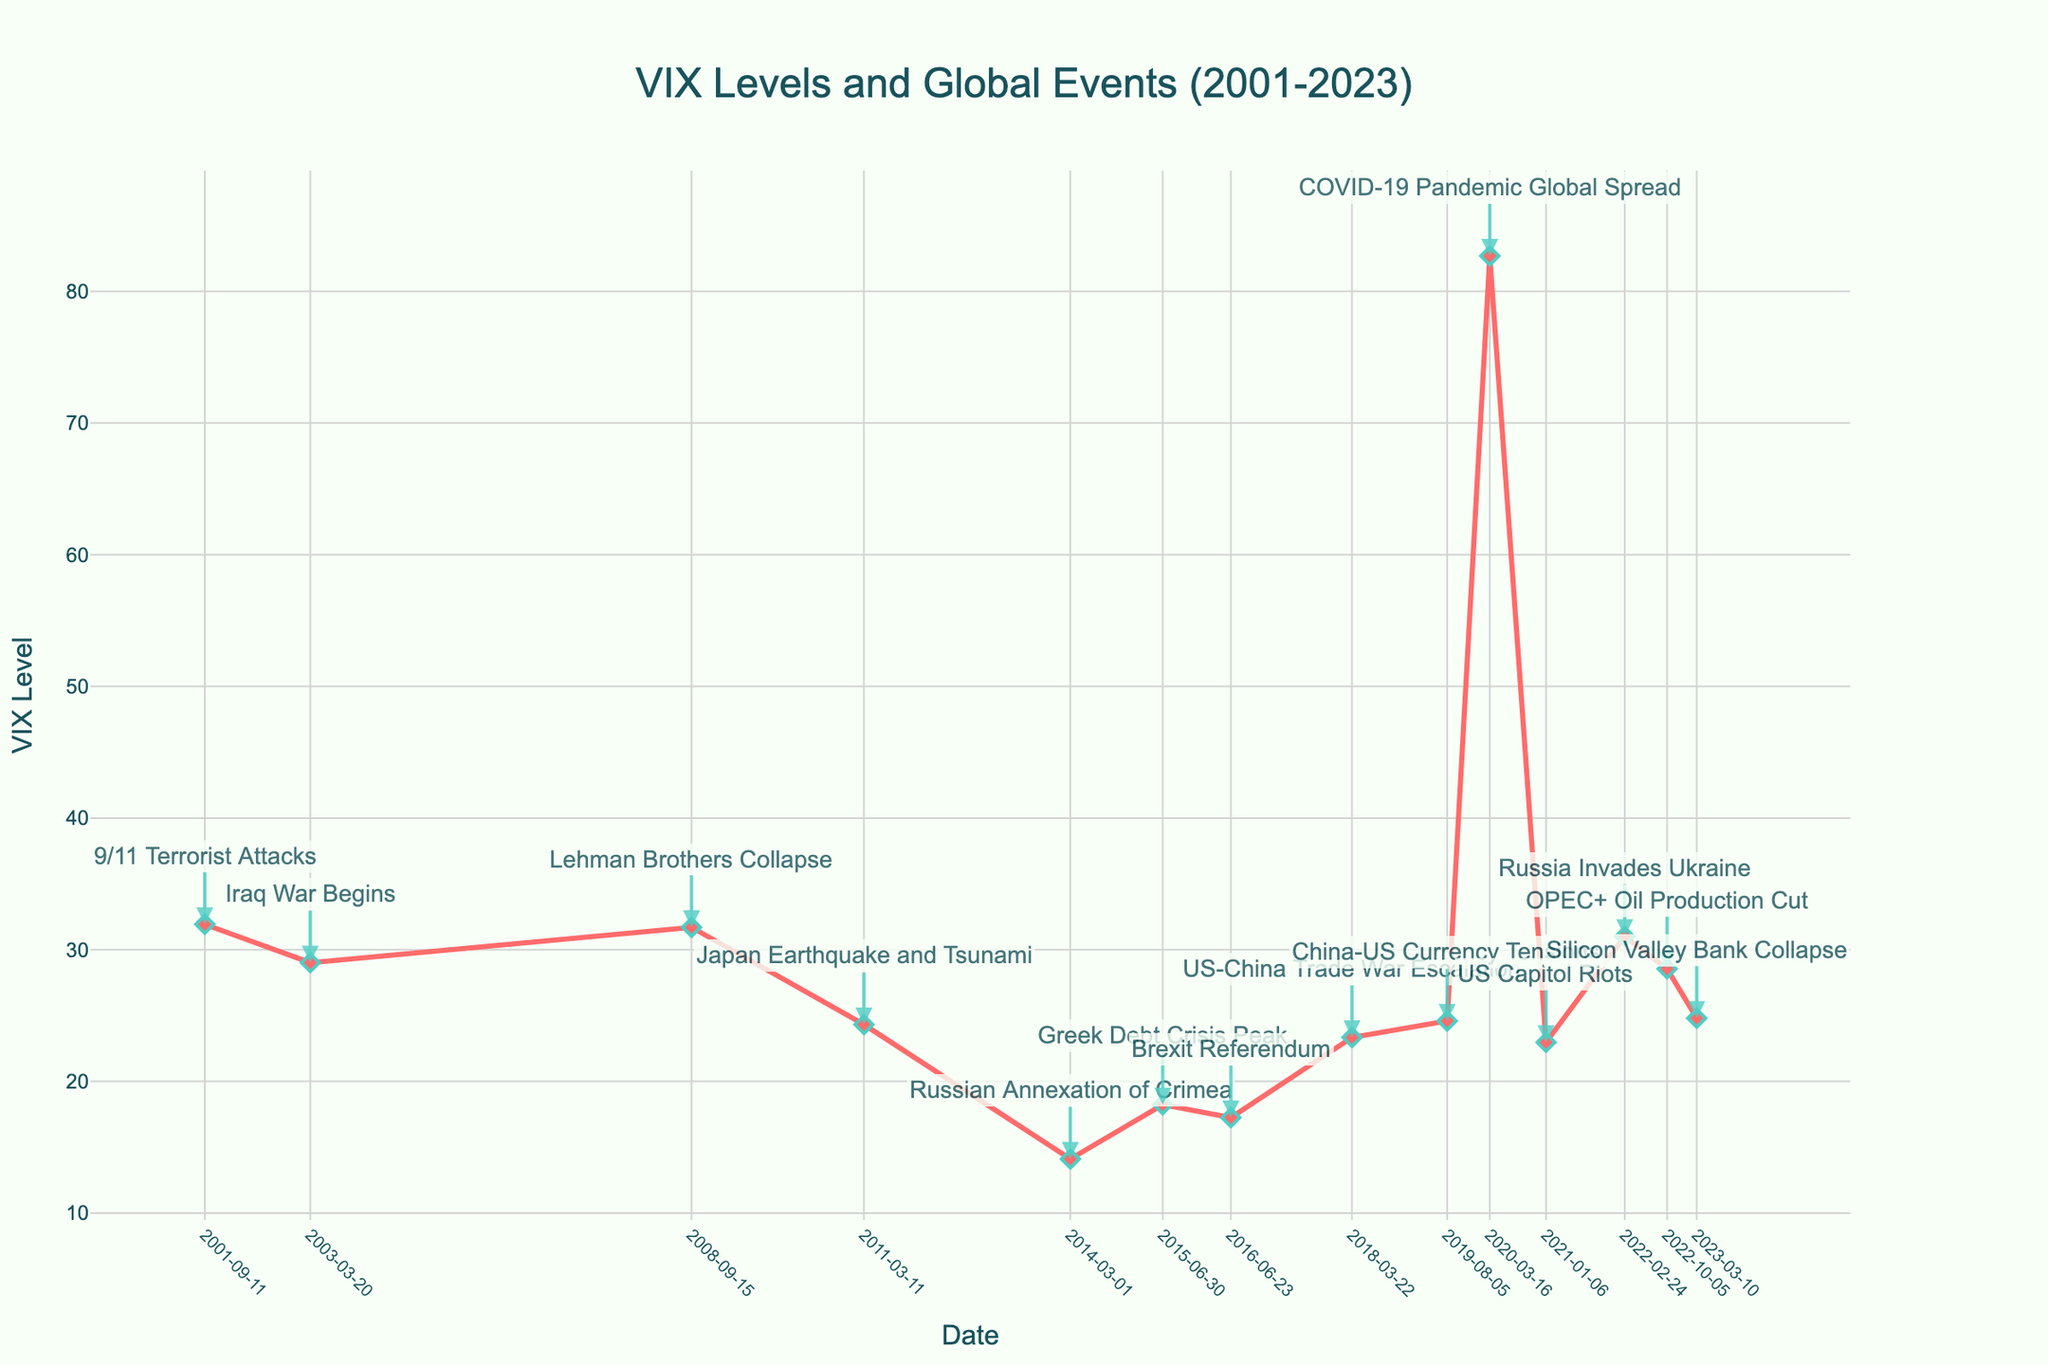What is the highest VIX level recorded in the given data? To find the highest VIX level, look at the vertical axis (VIX Level) and find the peak point. This highest point corresponds to the COVID-19 Pandemic Global Spread event in March 2020.
Answer: 82.69 Which event corresponds to the lowest VIX level? Examine the VIX levels for each event along the timeline. The Russian Annexation of Crimea in March 2014 has the lowest VIX level, observed at 14.11.
Answer: Russian Annexation of Crimea How does the VIX level in the event "Lehman Brothers Collapse" compare to "US Capitol Riots"? Look at the VIX levels for both events along the timeline. The Lehman Brothers Collapse in September 2008 has a VIX level of 31.70, while the US Capitol Riots in January 2021 has a VIX level of 22.97. Therefore, the VIX level is higher during the Lehman Brothers Collapse.
Answer: Higher Calculate the average VIX level for the events listed in 2022. There are two events in 2022: Russia Invades Ukraine (31.02) and OPEC+ Oil Production Cut (28.55). The average VIX level is calculated as (31.02 + 28.55)/2 = 29.785.
Answer: 29.785 Compare the VIX levels for the events "Brexit Referendum" and "Greek Debt Crisis Peak". Evaluate the VIX levels for these two events. Brexit Referendum has a VIX level of 17.25 in June 2016 and Greek Debt Crisis Peak has a VIX level of 18.23 in June 2015. The latter has a slightly higher VIX level.
Answer: Greek Debt Crisis Peak Identify the trend of the VIX level from "US-China Trade War Escalation" to "China-US Currency Tensions". Analyze the VIX levels over the timeline between these two events. The VIX level slightly increased from 23.34 during the US-China Trade War Escalation in March 2018 to 24.59 during China-US Currency Tensions in August 2019.
Answer: Slightly increased What is the difference in VIX levels between the "9/11 Terrorist Attacks" and the "Iraq War Begins"? The VIX level for the 9/11 Terrorist Attacks is 31.93 and for the Iraq War Begins is 29.02. The difference is calculated as 31.93 - 29.02 = 2.91.
Answer: 2.91 Determine if any events have VIX levels that are approximately equal (within 1 unit difference). Compare the VIX levels for all events. The "Lehman Brothers Collapse" (31.70) and "9/11 Terrorist Attacks" (31.93) have VIX levels within 1 unit.
Answer: Lehman Brothers Collapse and 9/11 Terrorist Attacks Is the VIX level for the "Silicon Valley Bank Collapse" higher or lower than the "Japan Earthquake and Tsunami"? Examine the VIX levels for both events. The Silicon Valley Bank Collapse in March 2023 has a VIX level of 24.80, while Japan Earthquake and Tsunami in March 2011 has a VIX level of 24.32. Therefore, the VIX level is slightly higher for the Silicon Valley Bank Collapse.
Answer: Higher 